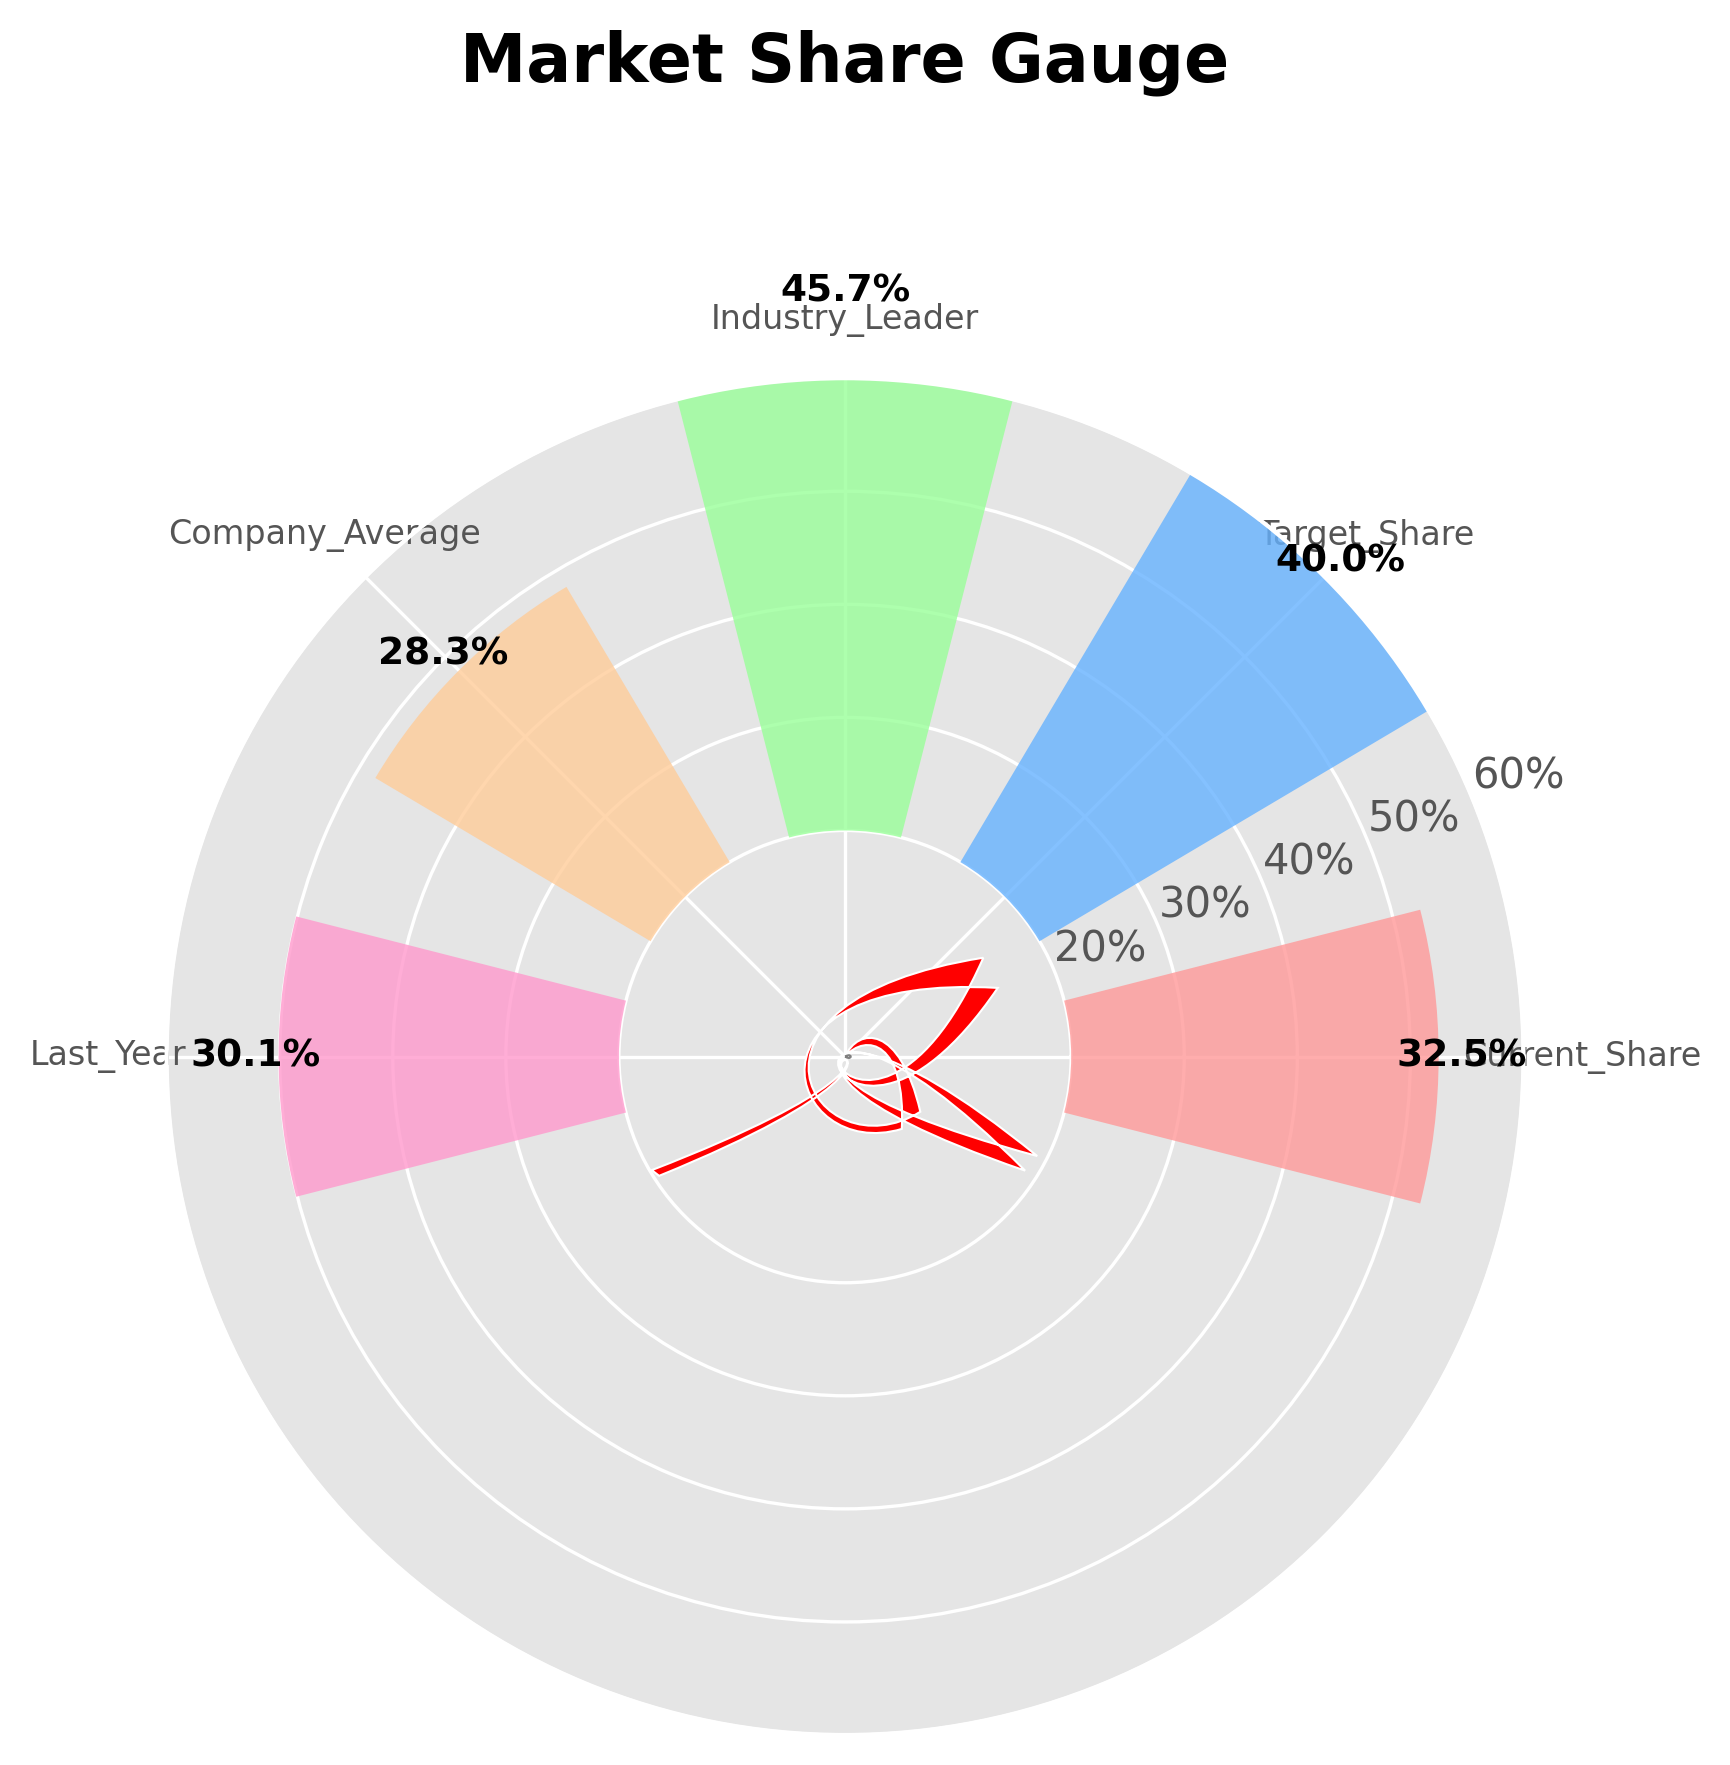What's the current market share percentage? The current market share percentage is represented by the 'Current_Share' section of the gauge, which points to the value labeled on the chart.
Answer: 32.5% What is the target market share percentage? The target market share percentage is shown in the 'Target_Share' section of the chart and labeled accordingly.
Answer: 40% Which category has the highest market share percentage on the gauge? By observing the labels and corresponding values, the 'Industry_Leader' section has the highest percentage.
Answer: Industry_Leader How does the current market share compare to the target market share? The current share is at 32.5%, while the target share is at 40%. The difference between the target share and current share is 40% - 32.5% = 7.5%.
Answer: The target is 7.5% higher What is the average market share percentage among all listed categories? Add all the percentages and divide by the number of categories: (32.5 + 40 + 45.7 + 28.3 + 30.1) / 5 = 176.6 / 5
Answer: 35.32% How does the company's average market share compare to last year? The company's average market share is 28.3%, and last year the market share was 30.1%. Calculate the difference: 30.1 - 28.3 = 1.8%.
Answer: 1.8% higher last year How far is the current share percentage from the industry leader's percentage? The industry leader's percentage is 45.7%, and the current share is 32.5%. Calculate the difference: 45.7 - 32.5 = 13.2%.
Answer: 13.2% behind What is the median market share percentage in the gauge chart? Order the percentages: 28.3%, 30.1%, 32.5%, 40%, 45.7%. The median value is the middle one in the ordered list, which is 32.5%.
Answer: 32.5% How much growth is needed from last year's market share to reach the target share? The target share is 40%, and last year the share was 30.1%. Calculate the needed growth: 40 - 30.1 = 9.9%.
Answer: 9.9% growth needed 